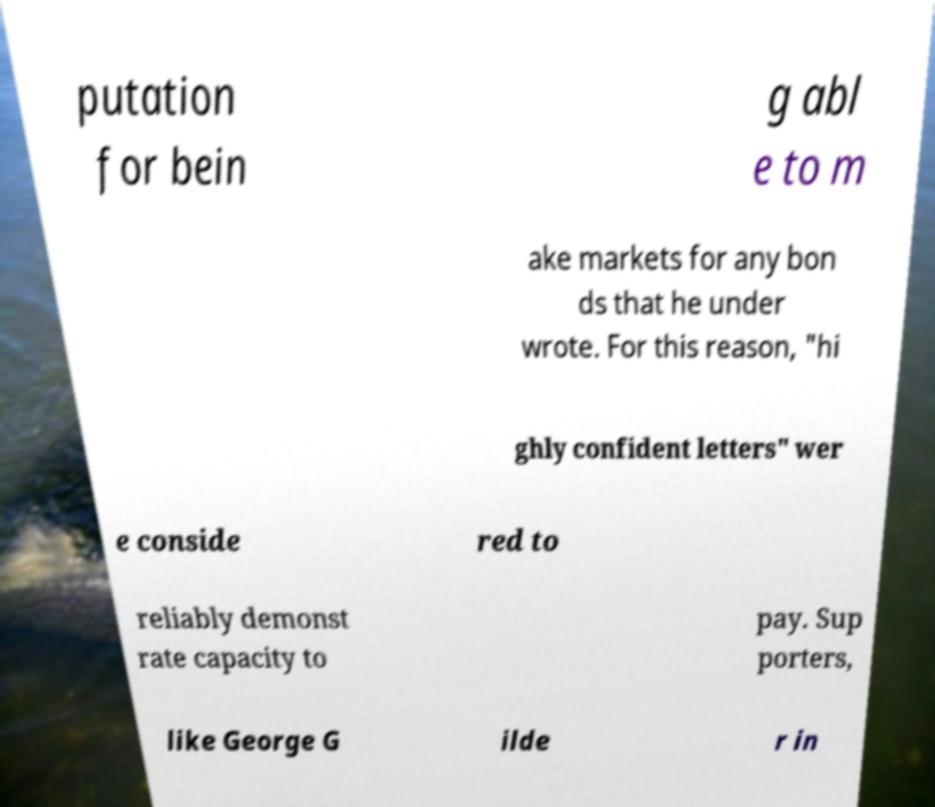There's text embedded in this image that I need extracted. Can you transcribe it verbatim? putation for bein g abl e to m ake markets for any bon ds that he under wrote. For this reason, "hi ghly confident letters" wer e conside red to reliably demonst rate capacity to pay. Sup porters, like George G ilde r in 